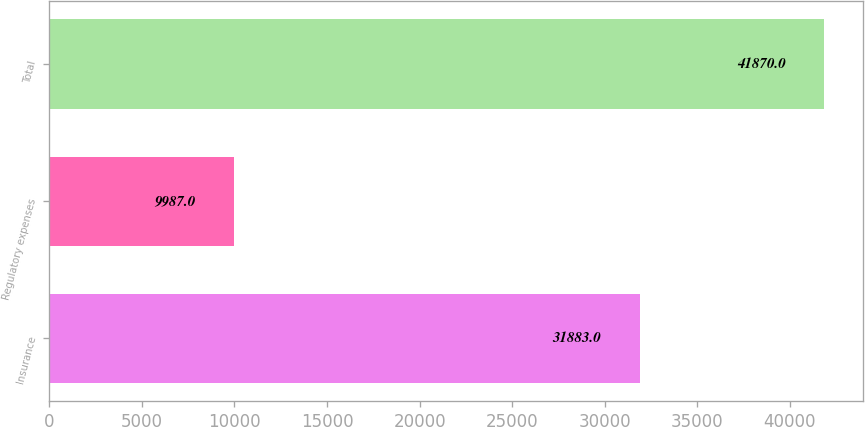<chart> <loc_0><loc_0><loc_500><loc_500><bar_chart><fcel>Insurance<fcel>Regulatory expenses<fcel>Total<nl><fcel>31883<fcel>9987<fcel>41870<nl></chart> 